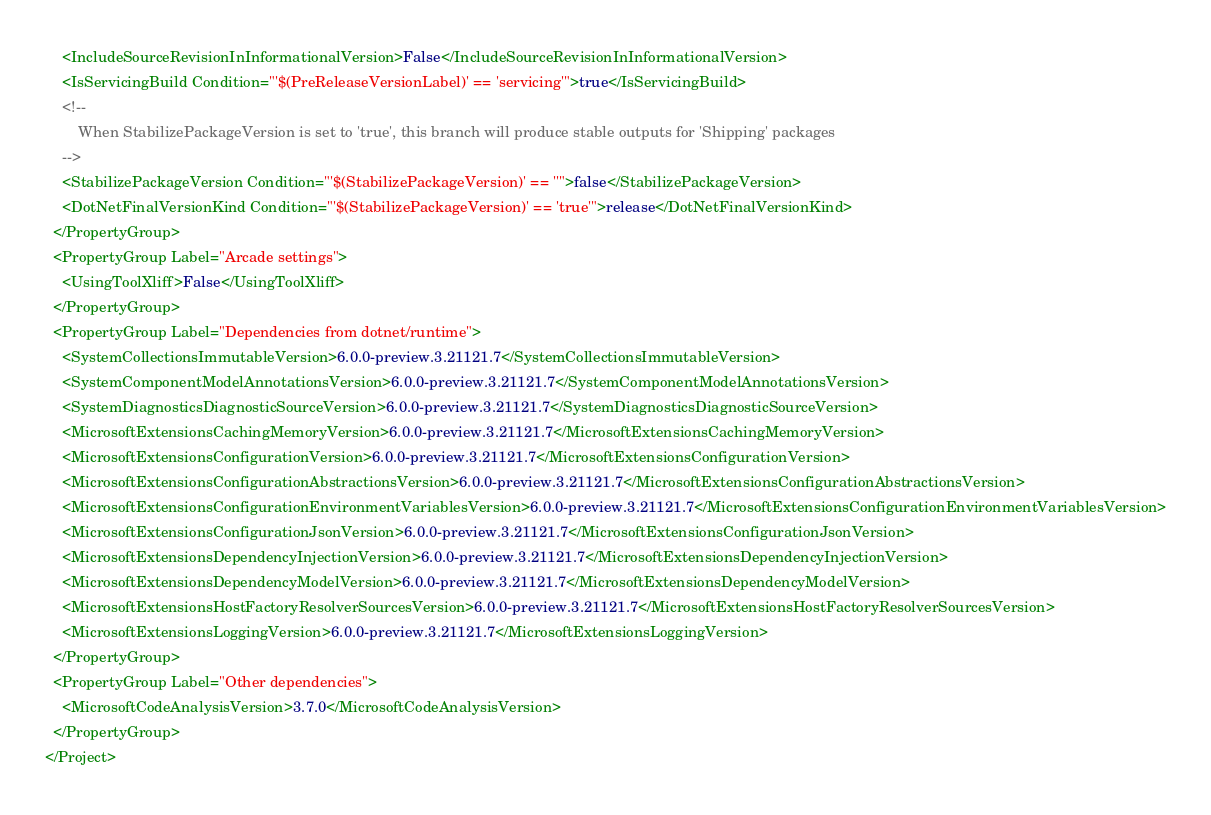Convert code to text. <code><loc_0><loc_0><loc_500><loc_500><_XML_>    <IncludeSourceRevisionInInformationalVersion>False</IncludeSourceRevisionInInformationalVersion>
    <IsServicingBuild Condition="'$(PreReleaseVersionLabel)' == 'servicing'">true</IsServicingBuild>
    <!--
        When StabilizePackageVersion is set to 'true', this branch will produce stable outputs for 'Shipping' packages
    -->
    <StabilizePackageVersion Condition="'$(StabilizePackageVersion)' == ''">false</StabilizePackageVersion>
    <DotNetFinalVersionKind Condition="'$(StabilizePackageVersion)' == 'true'">release</DotNetFinalVersionKind>
  </PropertyGroup>
  <PropertyGroup Label="Arcade settings">
    <UsingToolXliff>False</UsingToolXliff>
  </PropertyGroup>
  <PropertyGroup Label="Dependencies from dotnet/runtime">
    <SystemCollectionsImmutableVersion>6.0.0-preview.3.21121.7</SystemCollectionsImmutableVersion>
    <SystemComponentModelAnnotationsVersion>6.0.0-preview.3.21121.7</SystemComponentModelAnnotationsVersion>
    <SystemDiagnosticsDiagnosticSourceVersion>6.0.0-preview.3.21121.7</SystemDiagnosticsDiagnosticSourceVersion>
    <MicrosoftExtensionsCachingMemoryVersion>6.0.0-preview.3.21121.7</MicrosoftExtensionsCachingMemoryVersion>
    <MicrosoftExtensionsConfigurationVersion>6.0.0-preview.3.21121.7</MicrosoftExtensionsConfigurationVersion>
    <MicrosoftExtensionsConfigurationAbstractionsVersion>6.0.0-preview.3.21121.7</MicrosoftExtensionsConfigurationAbstractionsVersion>
    <MicrosoftExtensionsConfigurationEnvironmentVariablesVersion>6.0.0-preview.3.21121.7</MicrosoftExtensionsConfigurationEnvironmentVariablesVersion>
    <MicrosoftExtensionsConfigurationJsonVersion>6.0.0-preview.3.21121.7</MicrosoftExtensionsConfigurationJsonVersion>
    <MicrosoftExtensionsDependencyInjectionVersion>6.0.0-preview.3.21121.7</MicrosoftExtensionsDependencyInjectionVersion>
    <MicrosoftExtensionsDependencyModelVersion>6.0.0-preview.3.21121.7</MicrosoftExtensionsDependencyModelVersion>
    <MicrosoftExtensionsHostFactoryResolverSourcesVersion>6.0.0-preview.3.21121.7</MicrosoftExtensionsHostFactoryResolverSourcesVersion>
    <MicrosoftExtensionsLoggingVersion>6.0.0-preview.3.21121.7</MicrosoftExtensionsLoggingVersion>
  </PropertyGroup>
  <PropertyGroup Label="Other dependencies">
    <MicrosoftCodeAnalysisVersion>3.7.0</MicrosoftCodeAnalysisVersion>
  </PropertyGroup>
</Project>
</code> 